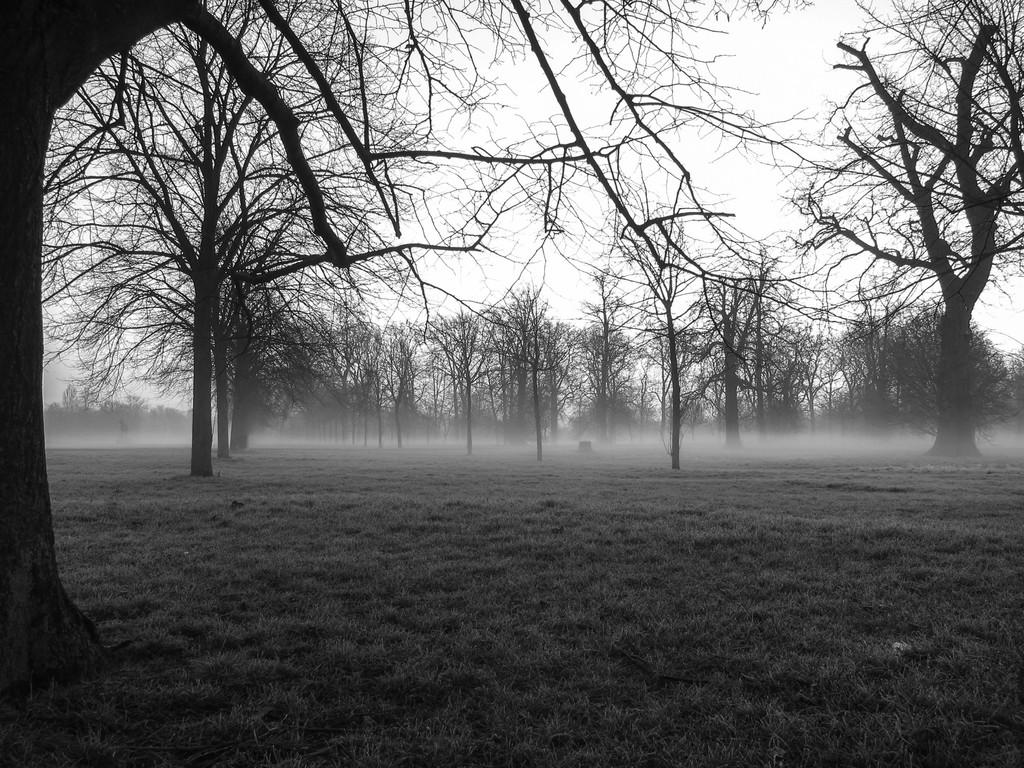What type of vegetation is present on the ground in the image? There is grass on the ground in the image. What is the condition of the trees in the image? The trees in the image are dry. Where is the friend playing with the rake and pail in the image? There is no friend, rake, or pail present in the image. 